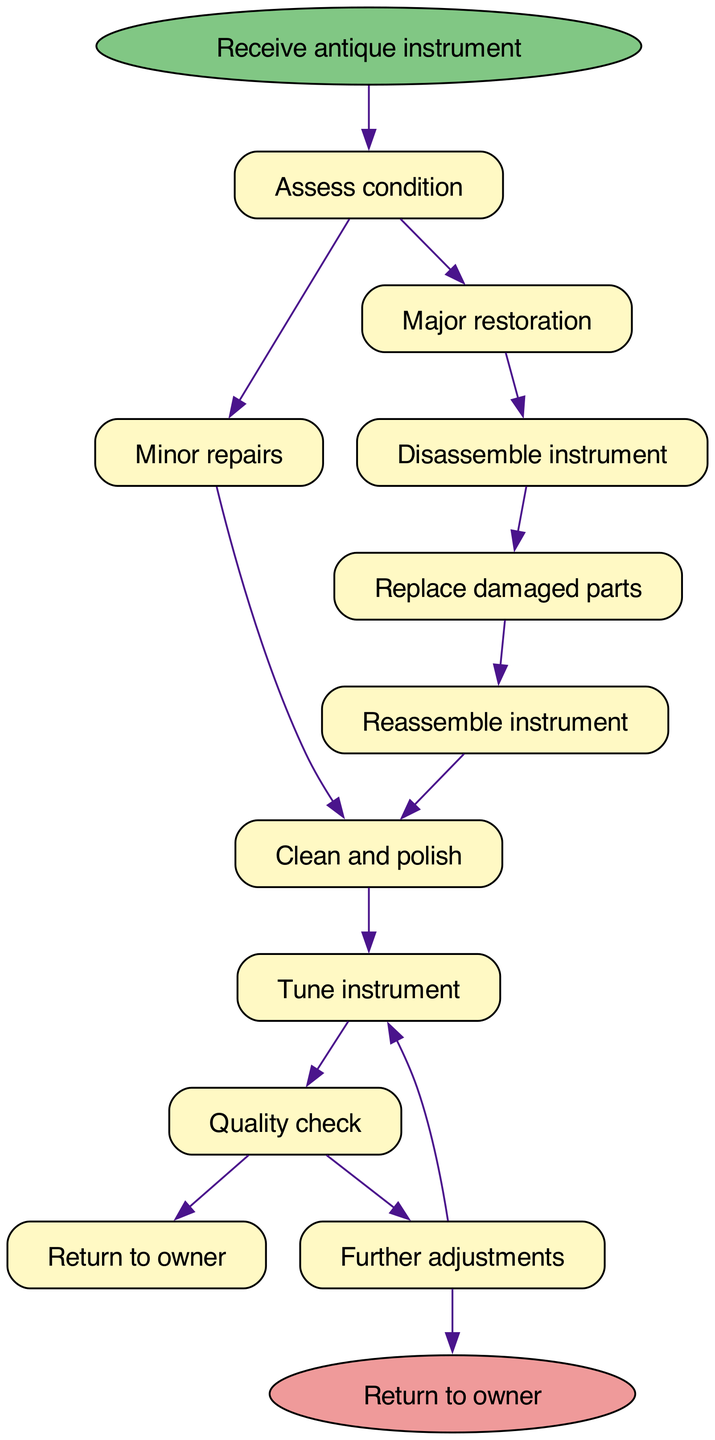What is the first step after receiving an antique instrument? The first step is "Assess condition". It is the direct next step shown in the diagram from the starting point, which indicates that the assessment is necessary immediately after receiving the instrument.
Answer: Assess condition How many steps are there in total? There are 10 steps listed in the diagram, including the starting point and the end point as part of the workflow. This can be counted by analyzing the number of process nodes defined in the steps list.
Answer: 10 What is the last action before returning the instrument to the owner? The last action before returning the instrument is "Quality check". This is the step immediately preceding the end node in the diagram, indicating that it is the final check done prior to returning.
Answer: Quality check What follows after "Tune instrument"? After "Tune instrument", the next step is "Quality check". This can be directly seen in the flow from the "Tune instrument" step leading into the "Quality check".
Answer: Quality check How does one proceed after "Further adjustments"? After "Further adjustments", you go back to "Tune instrument". In the workflow, there is a loop created here where if further adjustments are needed, you retune the instrument before proceeding forward again.
Answer: Tune instrument Which step involves replacing parts? The step that involves replacing parts is "Replace damaged parts". This step is clearly indicated in the workflow as needing to be done after disassembling the instrument.
Answer: Replace damaged parts What two outcomes can follow the "Quality check"? The two outcomes after "Quality check" are "Return to owner" and "Further adjustments". This is illustrated as a branching point in the diagram where either decision can be taken depending on the quality of the restoration.
Answer: Return to owner, Further adjustments What is the relationship between "Disassemble instrument" and "Replace damaged parts"? The relationship is sequential, where "Disassemble instrument" leads directly into "Replace damaged parts". This indicates that one must disassemble the instrument before any parts can be replaced, showing a necessary order of operations.
Answer: Sequential relationship How many edges connect to "Assess condition"? There is one outgoing edge from "Assess condition" that leads to either "Minor repairs" or "Major restoration", indicating that there are two pathways but just one edge emanating from this step.
Answer: 1 